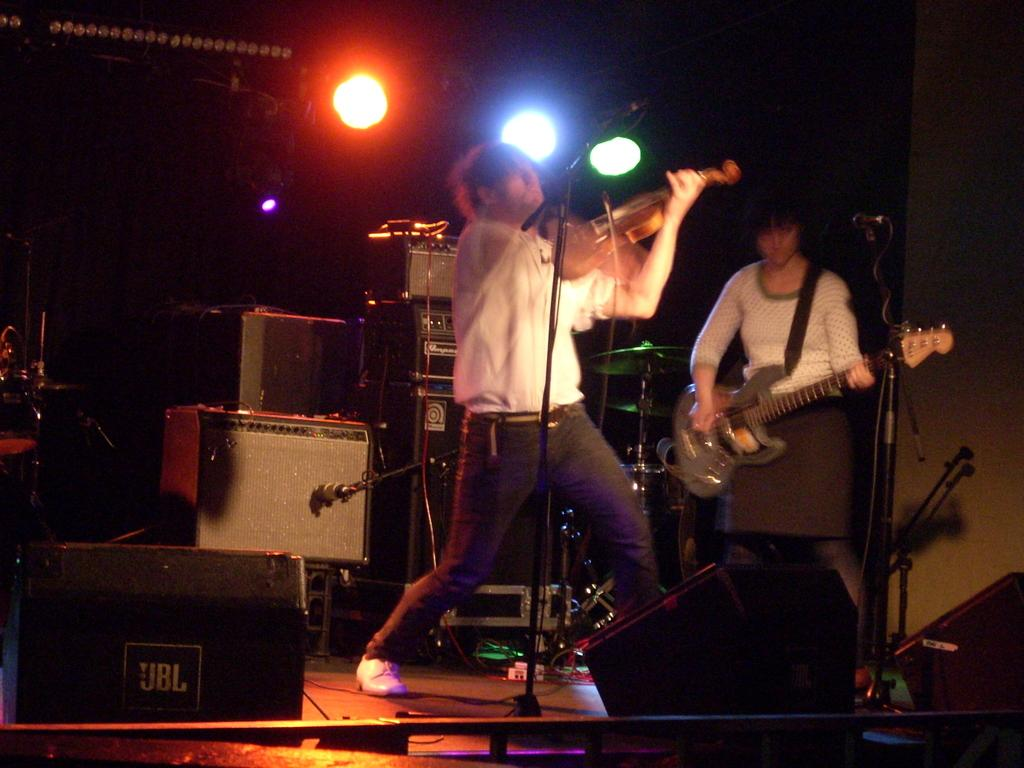Who are the people in the image? There is a man and a woman in the image. What are the man and woman holding in the image? The man is holding a guitar, and the woman is also holding a guitar. What type of shirt is the woman wearing in the image? There is no information about the woman's shirt in the image, so we cannot answer that question. 